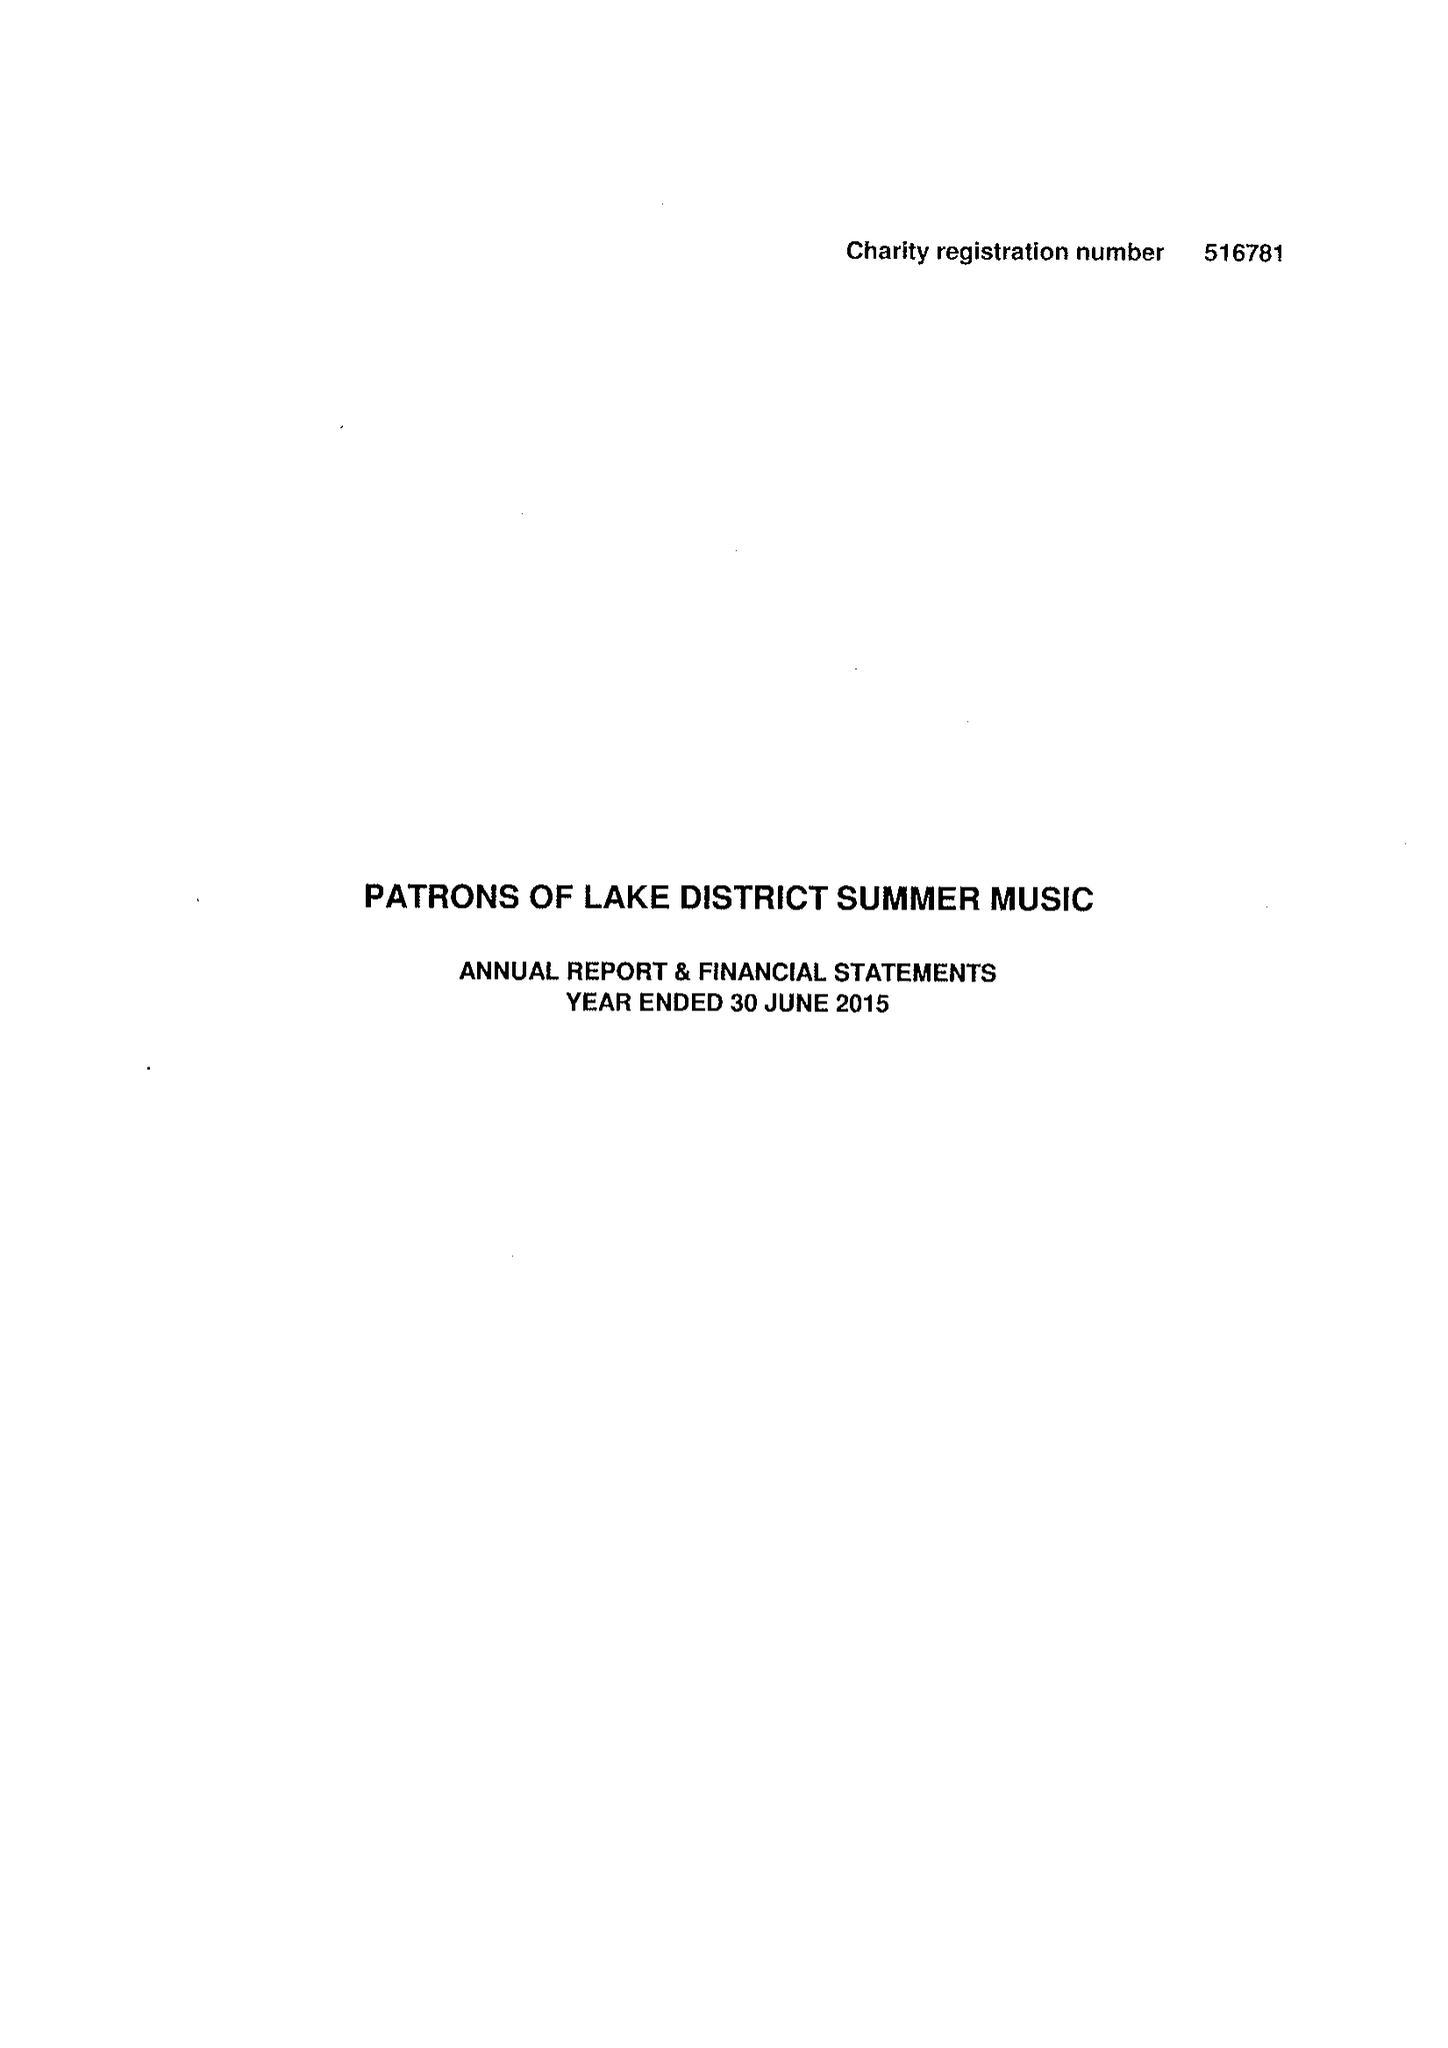What is the value for the spending_annually_in_british_pounds?
Answer the question using a single word or phrase. 21979.00 